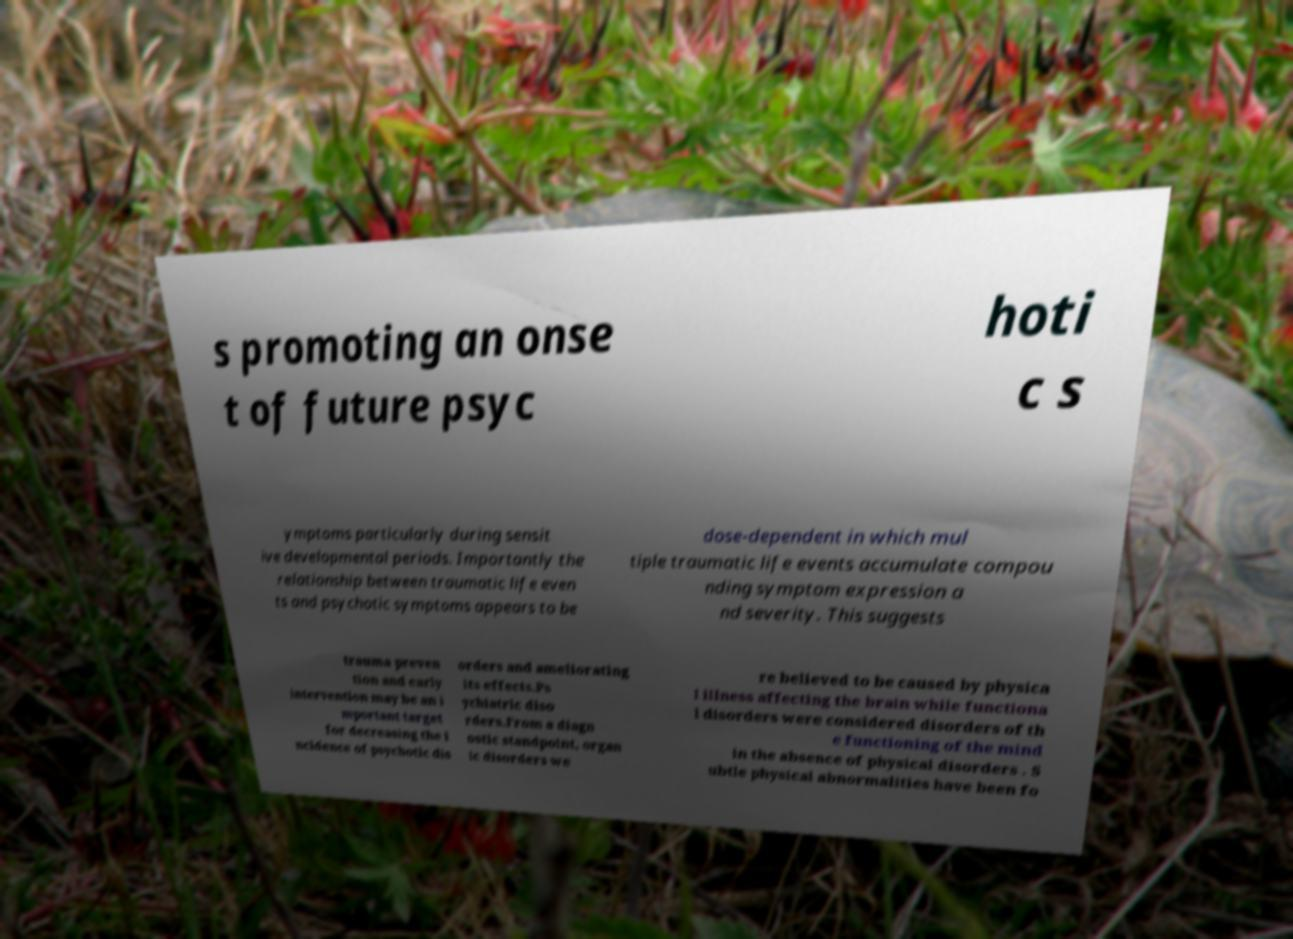Can you accurately transcribe the text from the provided image for me? s promoting an onse t of future psyc hoti c s ymptoms particularly during sensit ive developmental periods. Importantly the relationship between traumatic life even ts and psychotic symptoms appears to be dose-dependent in which mul tiple traumatic life events accumulate compou nding symptom expression a nd severity. This suggests trauma preven tion and early intervention may be an i mportant target for decreasing the i ncidence of psychotic dis orders and ameliorating its effects.Ps ychiatric diso rders.From a diagn ostic standpoint, organ ic disorders we re believed to be caused by physica l illness affecting the brain while functiona l disorders were considered disorders of th e functioning of the mind in the absence of physical disorders . S ubtle physical abnormalities have been fo 